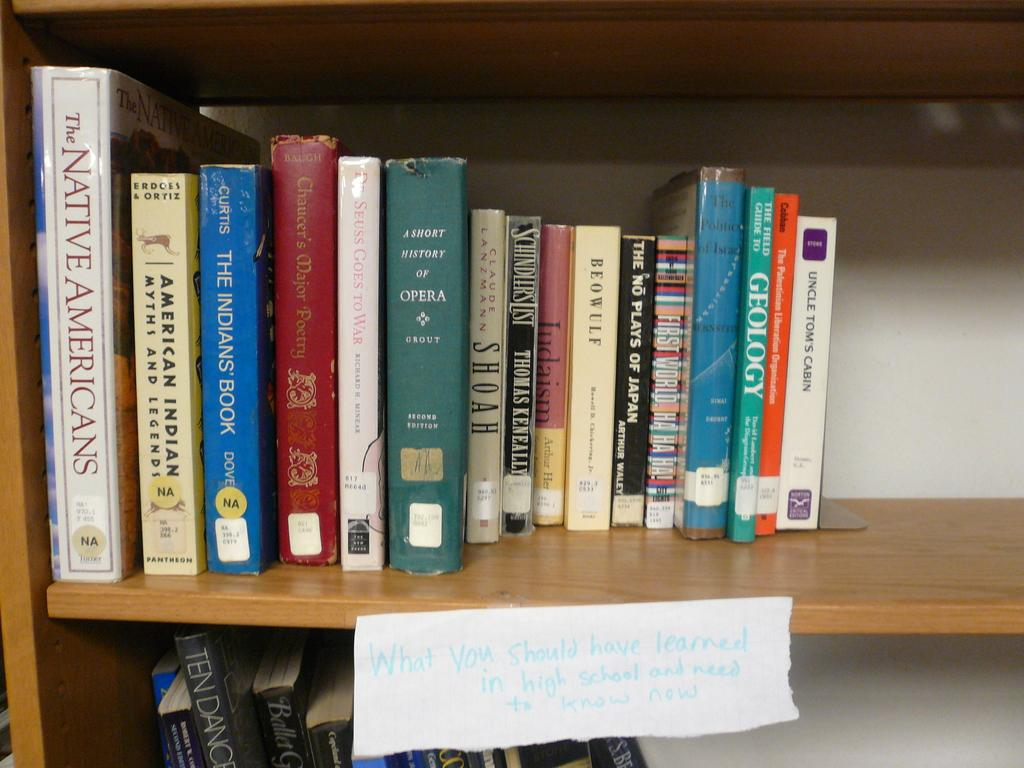<image>
Create a compact narrative representing the image presented. A book called The Native Americans is on a shelf next to American Indian Myths and Legends. 